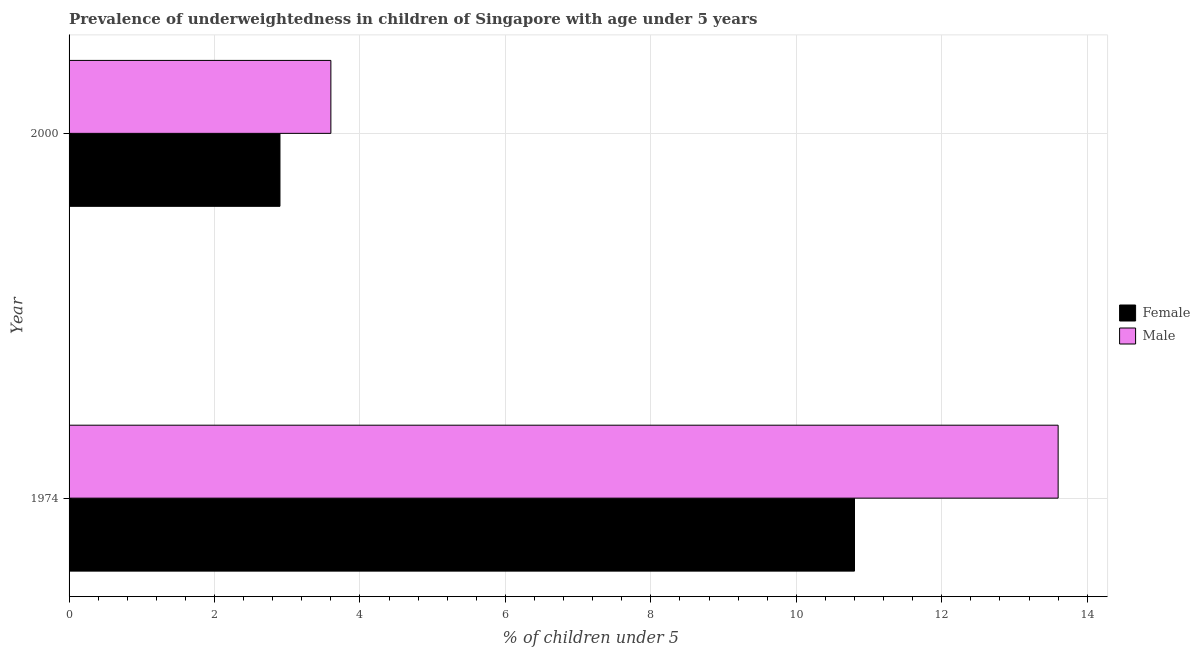How many different coloured bars are there?
Your response must be concise. 2. How many groups of bars are there?
Give a very brief answer. 2. Are the number of bars per tick equal to the number of legend labels?
Your response must be concise. Yes. Are the number of bars on each tick of the Y-axis equal?
Offer a terse response. Yes. How many bars are there on the 1st tick from the top?
Give a very brief answer. 2. What is the label of the 1st group of bars from the top?
Offer a very short reply. 2000. In how many cases, is the number of bars for a given year not equal to the number of legend labels?
Your answer should be compact. 0. What is the percentage of underweighted male children in 2000?
Offer a terse response. 3.6. Across all years, what is the maximum percentage of underweighted female children?
Your answer should be compact. 10.8. Across all years, what is the minimum percentage of underweighted male children?
Offer a very short reply. 3.6. In which year was the percentage of underweighted female children maximum?
Ensure brevity in your answer.  1974. In which year was the percentage of underweighted female children minimum?
Your response must be concise. 2000. What is the total percentage of underweighted female children in the graph?
Keep it short and to the point. 13.7. What is the difference between the percentage of underweighted female children in 2000 and the percentage of underweighted male children in 1974?
Your response must be concise. -10.7. What is the ratio of the percentage of underweighted female children in 1974 to that in 2000?
Offer a very short reply. 3.72. Is the percentage of underweighted male children in 1974 less than that in 2000?
Your answer should be compact. No. In how many years, is the percentage of underweighted male children greater than the average percentage of underweighted male children taken over all years?
Your response must be concise. 1. What does the 2nd bar from the top in 2000 represents?
Give a very brief answer. Female. What does the 2nd bar from the bottom in 1974 represents?
Your answer should be compact. Male. What is the difference between two consecutive major ticks on the X-axis?
Your answer should be very brief. 2. Are the values on the major ticks of X-axis written in scientific E-notation?
Ensure brevity in your answer.  No. Does the graph contain grids?
Offer a very short reply. Yes. Where does the legend appear in the graph?
Ensure brevity in your answer.  Center right. How are the legend labels stacked?
Make the answer very short. Vertical. What is the title of the graph?
Give a very brief answer. Prevalence of underweightedness in children of Singapore with age under 5 years. What is the label or title of the X-axis?
Keep it short and to the point.  % of children under 5. What is the  % of children under 5 of Female in 1974?
Give a very brief answer. 10.8. What is the  % of children under 5 in Male in 1974?
Keep it short and to the point. 13.6. What is the  % of children under 5 of Female in 2000?
Give a very brief answer. 2.9. What is the  % of children under 5 of Male in 2000?
Offer a terse response. 3.6. Across all years, what is the maximum  % of children under 5 in Female?
Make the answer very short. 10.8. Across all years, what is the maximum  % of children under 5 in Male?
Ensure brevity in your answer.  13.6. Across all years, what is the minimum  % of children under 5 of Female?
Keep it short and to the point. 2.9. Across all years, what is the minimum  % of children under 5 in Male?
Your answer should be very brief. 3.6. What is the difference between the  % of children under 5 in Female in 1974 and that in 2000?
Your answer should be compact. 7.9. What is the difference between the  % of children under 5 in Female in 1974 and the  % of children under 5 in Male in 2000?
Your answer should be compact. 7.2. What is the average  % of children under 5 of Female per year?
Ensure brevity in your answer.  6.85. What is the average  % of children under 5 of Male per year?
Your response must be concise. 8.6. In the year 2000, what is the difference between the  % of children under 5 of Female and  % of children under 5 of Male?
Ensure brevity in your answer.  -0.7. What is the ratio of the  % of children under 5 of Female in 1974 to that in 2000?
Your response must be concise. 3.72. What is the ratio of the  % of children under 5 of Male in 1974 to that in 2000?
Your answer should be compact. 3.78. What is the difference between the highest and the second highest  % of children under 5 of Female?
Your answer should be very brief. 7.9. What is the difference between the highest and the lowest  % of children under 5 of Female?
Ensure brevity in your answer.  7.9. 